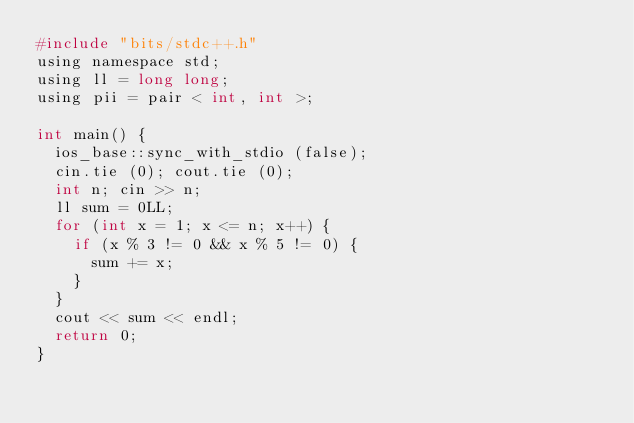<code> <loc_0><loc_0><loc_500><loc_500><_C_>#include "bits/stdc++.h"
using namespace std;
using ll = long long;
using pii = pair < int, int >;

int main() {
	ios_base::sync_with_stdio (false);
	cin.tie (0); cout.tie (0);
	int n; cin >> n;
	ll sum = 0LL;
	for (int x = 1; x <= n; x++) {
		if (x % 3 != 0 && x % 5 != 0) {
			sum += x;
		}
	}
	cout << sum << endl;
	return 0;
}
</code> 